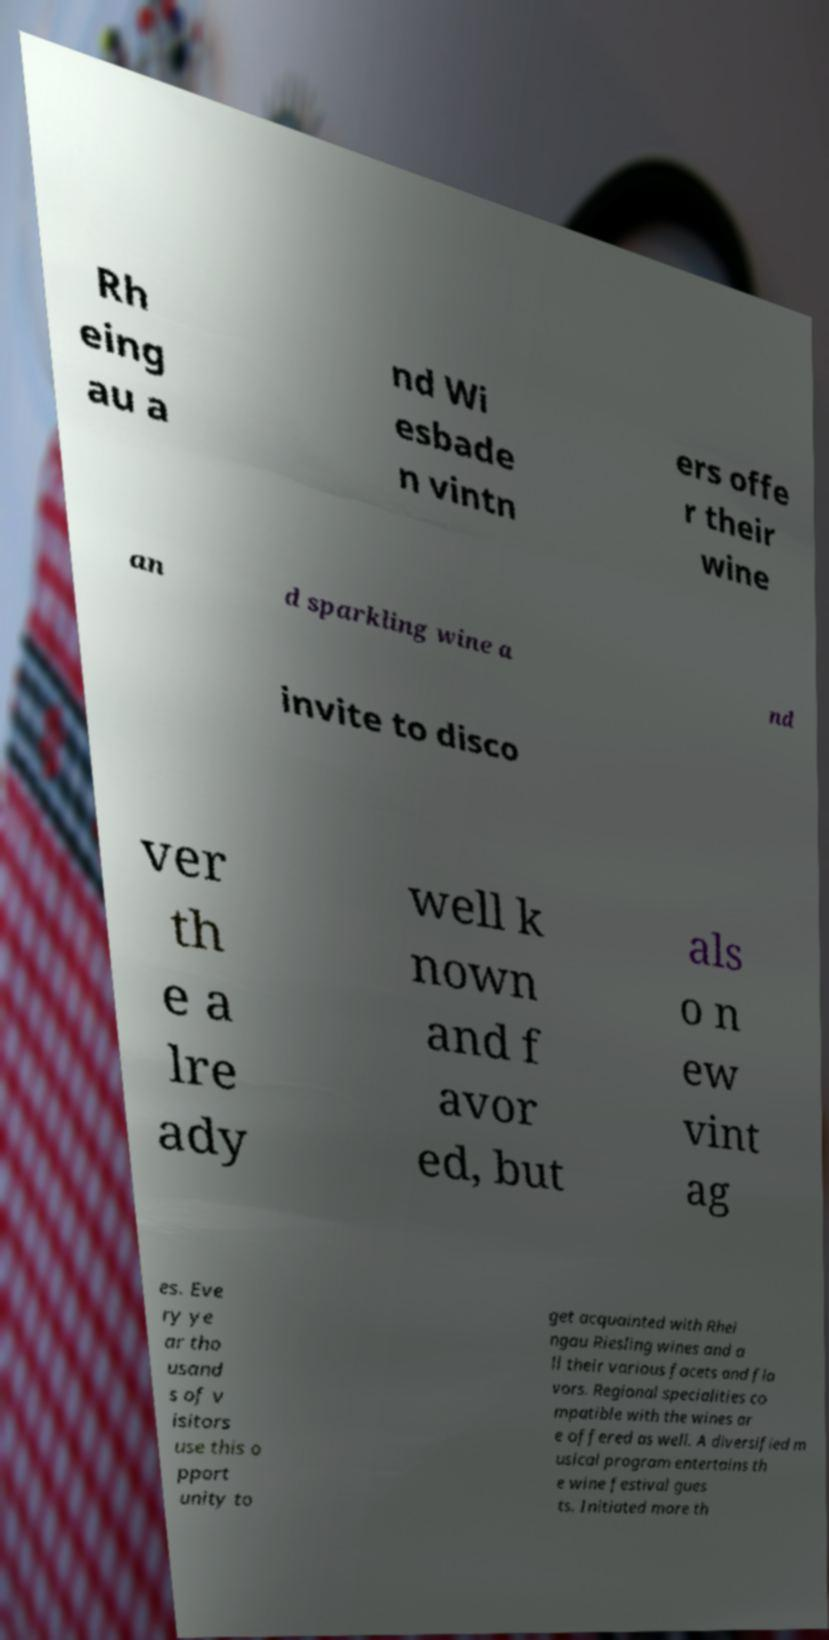What messages or text are displayed in this image? I need them in a readable, typed format. Rh eing au a nd Wi esbade n vintn ers offe r their wine an d sparkling wine a nd invite to disco ver th e a lre ady well k nown and f avor ed, but als o n ew vint ag es. Eve ry ye ar tho usand s of v isitors use this o pport unity to get acquainted with Rhei ngau Riesling wines and a ll their various facets and fla vors. Regional specialities co mpatible with the wines ar e offered as well. A diversified m usical program entertains th e wine festival gues ts. Initiated more th 